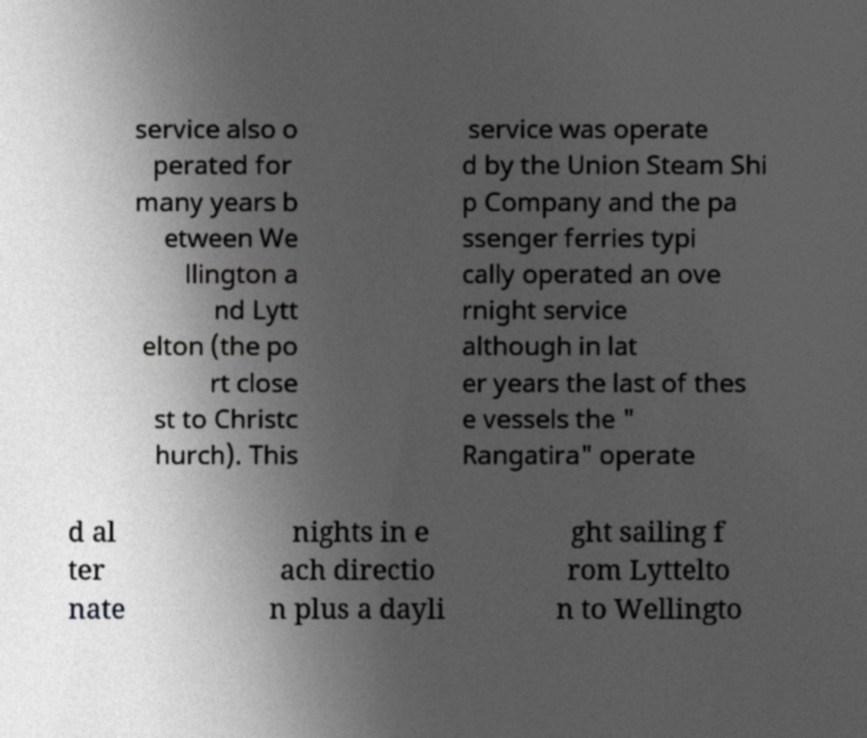Please identify and transcribe the text found in this image. service also o perated for many years b etween We llington a nd Lytt elton (the po rt close st to Christc hurch). This service was operate d by the Union Steam Shi p Company and the pa ssenger ferries typi cally operated an ove rnight service although in lat er years the last of thes e vessels the " Rangatira" operate d al ter nate nights in e ach directio n plus a dayli ght sailing f rom Lyttelto n to Wellingto 